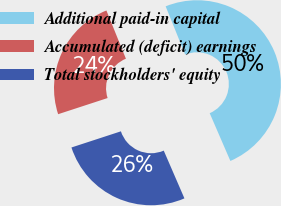<chart> <loc_0><loc_0><loc_500><loc_500><pie_chart><fcel>Additional paid-in capital<fcel>Accumulated (deficit) earnings<fcel>Total stockholders' equity<nl><fcel>49.61%<fcel>23.91%<fcel>26.48%<nl></chart> 